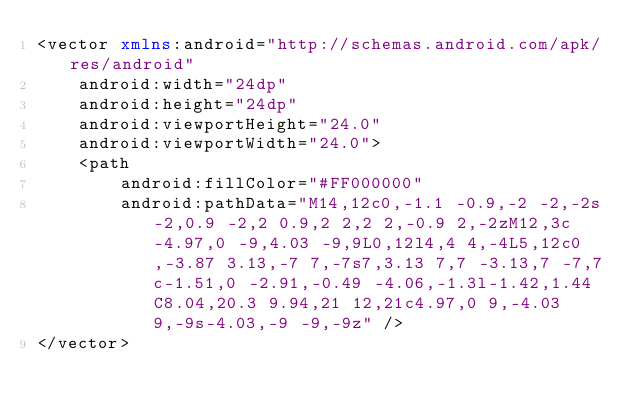Convert code to text. <code><loc_0><loc_0><loc_500><loc_500><_XML_><vector xmlns:android="http://schemas.android.com/apk/res/android"
    android:width="24dp"
    android:height="24dp"
    android:viewportHeight="24.0"
    android:viewportWidth="24.0">
    <path
        android:fillColor="#FF000000"
        android:pathData="M14,12c0,-1.1 -0.9,-2 -2,-2s-2,0.9 -2,2 0.9,2 2,2 2,-0.9 2,-2zM12,3c-4.97,0 -9,4.03 -9,9L0,12l4,4 4,-4L5,12c0,-3.87 3.13,-7 7,-7s7,3.13 7,7 -3.13,7 -7,7c-1.51,0 -2.91,-0.49 -4.06,-1.3l-1.42,1.44C8.04,20.3 9.94,21 12,21c4.97,0 9,-4.03 9,-9s-4.03,-9 -9,-9z" />
</vector>
</code> 